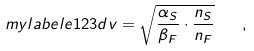Convert formula to latex. <formula><loc_0><loc_0><loc_500><loc_500>\ m y l a b e l { e 1 2 3 d } v = \sqrt { \frac { \alpha _ { S } } { \beta _ { F } } \cdot \frac { n _ { S } } { n _ { F } } } \quad ,</formula> 